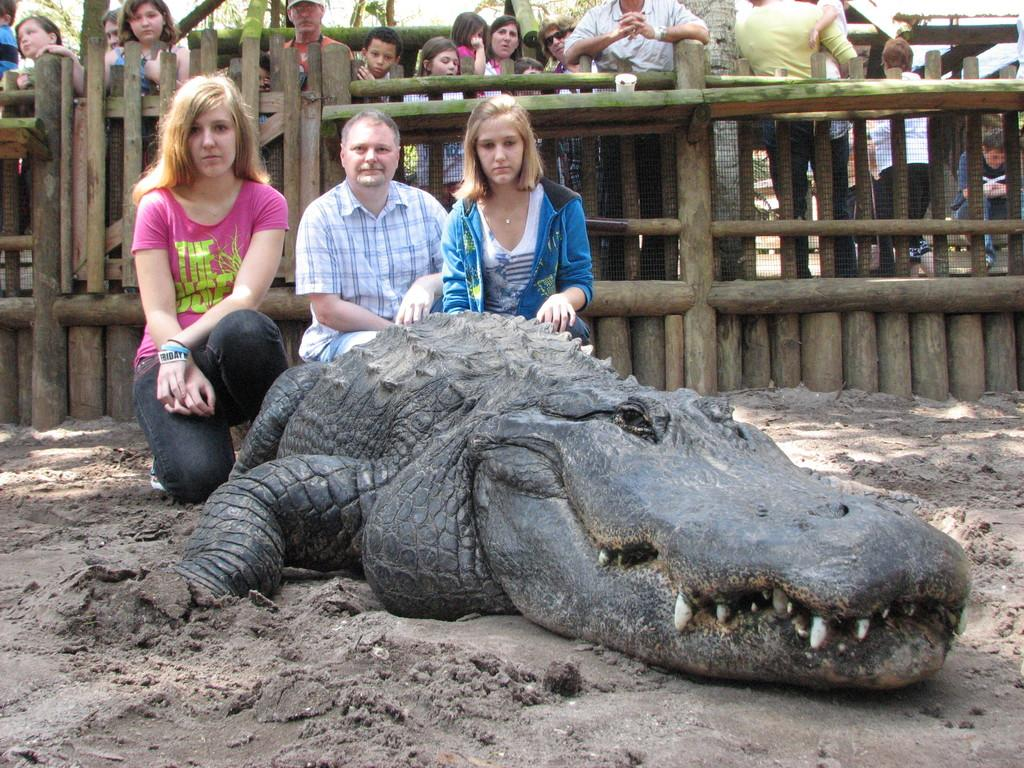How many people are present in the image? There are three persons in the image. What is the unusual creature in the image? There is an alligator in the image. What can be seen in the background of the image? There is a wooden fence and a group of people in the background of the image. Where can the books be found in the image? There are no books present in the image. What type of beam is supporting the alligator in the image? There is no beam present in the image, and the alligator is not being supported by any beam. 